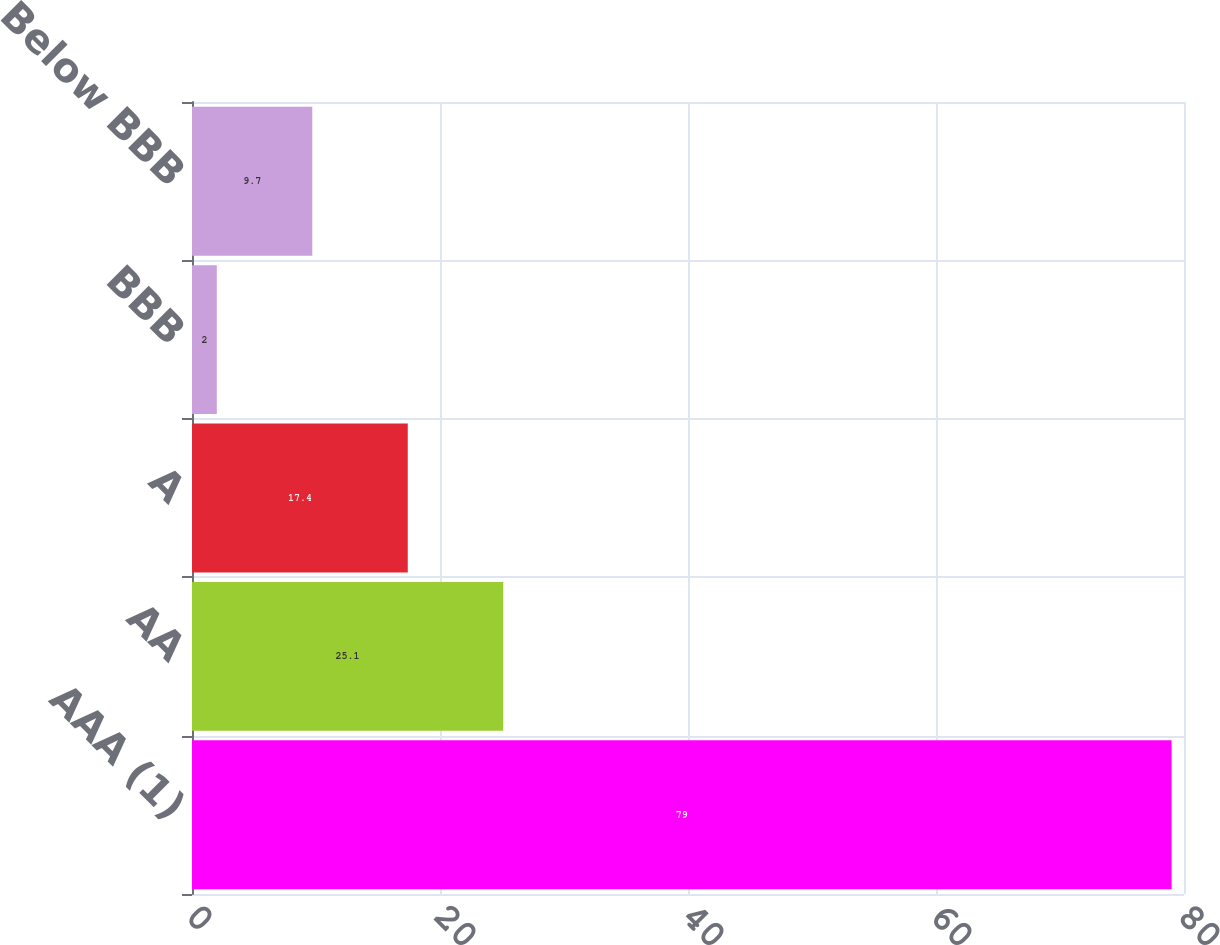Convert chart. <chart><loc_0><loc_0><loc_500><loc_500><bar_chart><fcel>AAA (1)<fcel>AA<fcel>A<fcel>BBB<fcel>Below BBB<nl><fcel>79<fcel>25.1<fcel>17.4<fcel>2<fcel>9.7<nl></chart> 